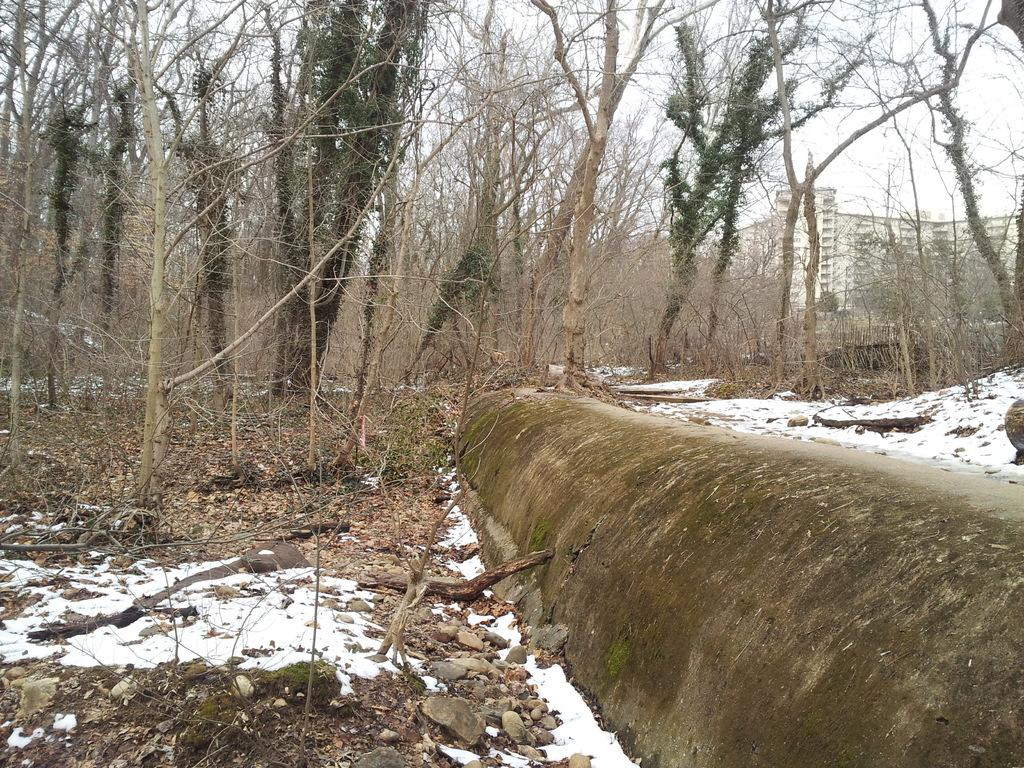What type of natural elements can be seen in the image? There are trees, stones, and twigs in the image. What type of structure is visible in the background of the image? There is a building in the background of the image. What is the color of the building in the image? The building is white in color. What type of vegetable is being discussed in the meeting in the image? There is no meeting or discussion of vegetables present in the image. 